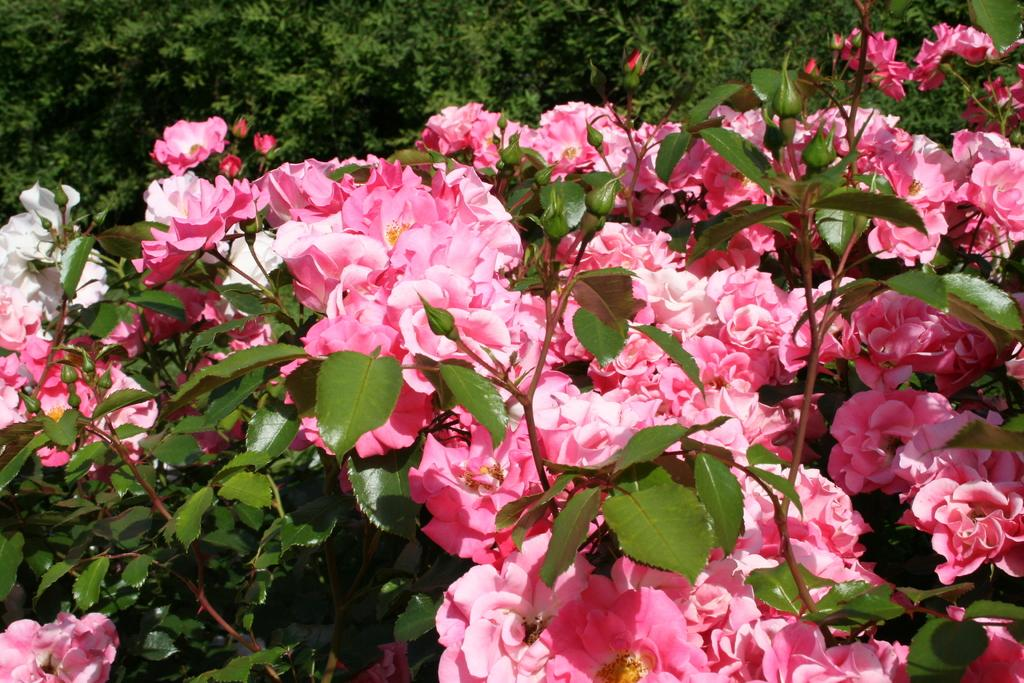What type of flora can be seen in the image? There are flowers in the image. What colors are the flowers? The flowers are pink and white in color. What other plant elements are visible beside the flowers? There are leaves beside the flowers. What can be seen in the background of the image? There are trees in the background of the image. What type of oil is being used to create the smoke in the image? There is no oil or smoke present in the image; it features flowers, leaves, and trees. 